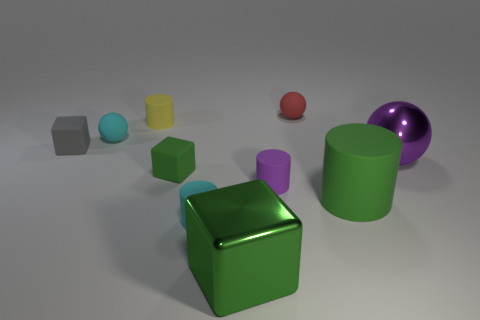Subtract all cyan cylinders. How many cylinders are left? 3 Subtract 0 brown cylinders. How many objects are left? 10 Subtract all blocks. How many objects are left? 7 Subtract all small purple rubber things. Subtract all large cylinders. How many objects are left? 8 Add 1 tiny cyan cylinders. How many tiny cyan cylinders are left? 2 Add 2 small gray objects. How many small gray objects exist? 3 